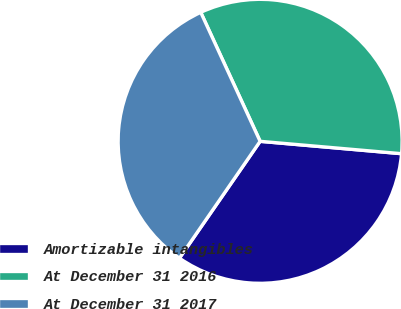Convert chart to OTSL. <chart><loc_0><loc_0><loc_500><loc_500><pie_chart><fcel>Amortizable intangibles<fcel>At December 31 2016<fcel>At December 31 2017<nl><fcel>33.23%<fcel>33.26%<fcel>33.52%<nl></chart> 